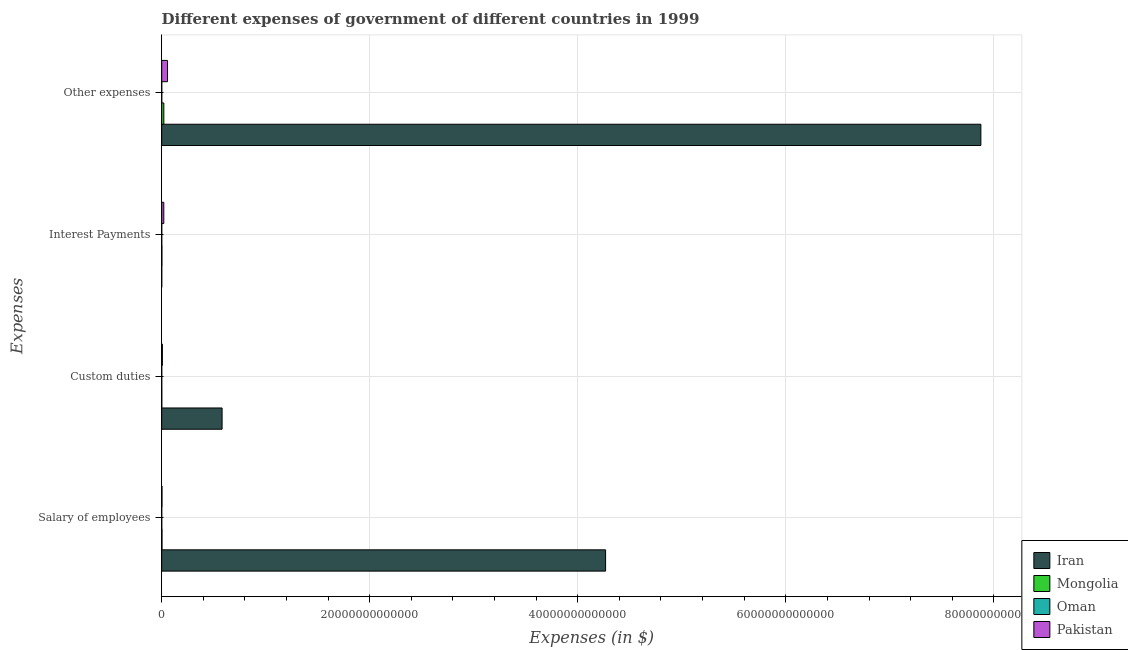How many different coloured bars are there?
Ensure brevity in your answer.  4. Are the number of bars on each tick of the Y-axis equal?
Offer a very short reply. Yes. How many bars are there on the 1st tick from the bottom?
Provide a succinct answer. 4. What is the label of the 4th group of bars from the top?
Your answer should be compact. Salary of employees. What is the amount spent on salary of employees in Iran?
Your answer should be compact. 4.27e+13. Across all countries, what is the maximum amount spent on custom duties?
Your answer should be very brief. 5.81e+12. Across all countries, what is the minimum amount spent on salary of employees?
Keep it short and to the point. 5.70e+08. In which country was the amount spent on other expenses maximum?
Give a very brief answer. Iran. In which country was the amount spent on interest payments minimum?
Keep it short and to the point. Iran. What is the total amount spent on interest payments in the graph?
Provide a short and direct response. 2.17e+11. What is the difference between the amount spent on other expenses in Oman and that in Iran?
Provide a succinct answer. -7.88e+13. What is the difference between the amount spent on other expenses in Pakistan and the amount spent on custom duties in Iran?
Make the answer very short. -5.25e+12. What is the average amount spent on other expenses per country?
Provide a short and direct response. 1.99e+13. What is the difference between the amount spent on salary of employees and amount spent on interest payments in Oman?
Give a very brief answer. 4.71e+08. In how many countries, is the amount spent on interest payments greater than 36000000000000 $?
Ensure brevity in your answer.  0. What is the ratio of the amount spent on interest payments in Mongolia to that in Iran?
Keep it short and to the point. 298.24. Is the difference between the amount spent on interest payments in Mongolia and Iran greater than the difference between the amount spent on salary of employees in Mongolia and Iran?
Make the answer very short. Yes. What is the difference between the highest and the second highest amount spent on other expenses?
Ensure brevity in your answer.  7.82e+13. What is the difference between the highest and the lowest amount spent on custom duties?
Keep it short and to the point. 5.81e+12. In how many countries, is the amount spent on salary of employees greater than the average amount spent on salary of employees taken over all countries?
Provide a short and direct response. 1. Is the sum of the amount spent on interest payments in Mongolia and Pakistan greater than the maximum amount spent on salary of employees across all countries?
Your response must be concise. No. Is it the case that in every country, the sum of the amount spent on interest payments and amount spent on other expenses is greater than the sum of amount spent on salary of employees and amount spent on custom duties?
Ensure brevity in your answer.  No. What does the 4th bar from the top in Salary of employees represents?
Give a very brief answer. Iran. What does the 3rd bar from the bottom in Salary of employees represents?
Your response must be concise. Oman. Is it the case that in every country, the sum of the amount spent on salary of employees and amount spent on custom duties is greater than the amount spent on interest payments?
Make the answer very short. No. How many bars are there?
Your answer should be compact. 16. How many countries are there in the graph?
Provide a short and direct response. 4. What is the difference between two consecutive major ticks on the X-axis?
Give a very brief answer. 2.00e+13. Does the graph contain any zero values?
Your answer should be compact. No. Where does the legend appear in the graph?
Your response must be concise. Bottom right. How many legend labels are there?
Your response must be concise. 4. What is the title of the graph?
Make the answer very short. Different expenses of government of different countries in 1999. What is the label or title of the X-axis?
Make the answer very short. Expenses (in $). What is the label or title of the Y-axis?
Offer a very short reply. Expenses. What is the Expenses (in $) of Iran in Salary of employees?
Offer a terse response. 4.27e+13. What is the Expenses (in $) of Mongolia in Salary of employees?
Keep it short and to the point. 2.57e+1. What is the Expenses (in $) of Oman in Salary of employees?
Your response must be concise. 5.70e+08. What is the Expenses (in $) of Pakistan in Salary of employees?
Offer a terse response. 2.48e+1. What is the Expenses (in $) of Iran in Custom duties?
Your response must be concise. 5.81e+12. What is the Expenses (in $) in Mongolia in Custom duties?
Give a very brief answer. 5.85e+09. What is the Expenses (in $) in Oman in Custom duties?
Your answer should be very brief. 8.03e+07. What is the Expenses (in $) in Pakistan in Custom duties?
Give a very brief answer. 6.53e+1. What is the Expenses (in $) of Iran in Interest Payments?
Offer a very short reply. 5.80e+07. What is the Expenses (in $) of Mongolia in Interest Payments?
Your answer should be compact. 1.73e+1. What is the Expenses (in $) of Oman in Interest Payments?
Provide a short and direct response. 9.88e+07. What is the Expenses (in $) of Pakistan in Interest Payments?
Offer a terse response. 2.00e+11. What is the Expenses (in $) of Iran in Other expenses?
Give a very brief answer. 7.88e+13. What is the Expenses (in $) of Mongolia in Other expenses?
Give a very brief answer. 2.04e+11. What is the Expenses (in $) in Oman in Other expenses?
Make the answer very short. 1.71e+09. What is the Expenses (in $) in Pakistan in Other expenses?
Your response must be concise. 5.58e+11. Across all Expenses, what is the maximum Expenses (in $) in Iran?
Provide a succinct answer. 7.88e+13. Across all Expenses, what is the maximum Expenses (in $) of Mongolia?
Keep it short and to the point. 2.04e+11. Across all Expenses, what is the maximum Expenses (in $) in Oman?
Ensure brevity in your answer.  1.71e+09. Across all Expenses, what is the maximum Expenses (in $) in Pakistan?
Offer a very short reply. 5.58e+11. Across all Expenses, what is the minimum Expenses (in $) of Iran?
Keep it short and to the point. 5.80e+07. Across all Expenses, what is the minimum Expenses (in $) in Mongolia?
Provide a short and direct response. 5.85e+09. Across all Expenses, what is the minimum Expenses (in $) of Oman?
Your response must be concise. 8.03e+07. Across all Expenses, what is the minimum Expenses (in $) of Pakistan?
Your answer should be compact. 2.48e+1. What is the total Expenses (in $) of Iran in the graph?
Keep it short and to the point. 1.27e+14. What is the total Expenses (in $) in Mongolia in the graph?
Your response must be concise. 2.53e+11. What is the total Expenses (in $) of Oman in the graph?
Give a very brief answer. 2.46e+09. What is the total Expenses (in $) in Pakistan in the graph?
Your response must be concise. 8.48e+11. What is the difference between the Expenses (in $) of Iran in Salary of employees and that in Custom duties?
Keep it short and to the point. 3.69e+13. What is the difference between the Expenses (in $) of Mongolia in Salary of employees and that in Custom duties?
Ensure brevity in your answer.  1.98e+1. What is the difference between the Expenses (in $) of Oman in Salary of employees and that in Custom duties?
Offer a very short reply. 4.89e+08. What is the difference between the Expenses (in $) in Pakistan in Salary of employees and that in Custom duties?
Offer a very short reply. -4.05e+1. What is the difference between the Expenses (in $) in Iran in Salary of employees and that in Interest Payments?
Keep it short and to the point. 4.27e+13. What is the difference between the Expenses (in $) in Mongolia in Salary of employees and that in Interest Payments?
Give a very brief answer. 8.39e+09. What is the difference between the Expenses (in $) of Oman in Salary of employees and that in Interest Payments?
Make the answer very short. 4.71e+08. What is the difference between the Expenses (in $) of Pakistan in Salary of employees and that in Interest Payments?
Your answer should be very brief. -1.75e+11. What is the difference between the Expenses (in $) of Iran in Salary of employees and that in Other expenses?
Offer a terse response. -3.61e+13. What is the difference between the Expenses (in $) in Mongolia in Salary of employees and that in Other expenses?
Give a very brief answer. -1.79e+11. What is the difference between the Expenses (in $) in Oman in Salary of employees and that in Other expenses?
Your response must be concise. -1.14e+09. What is the difference between the Expenses (in $) in Pakistan in Salary of employees and that in Other expenses?
Ensure brevity in your answer.  -5.33e+11. What is the difference between the Expenses (in $) in Iran in Custom duties and that in Interest Payments?
Provide a short and direct response. 5.81e+12. What is the difference between the Expenses (in $) in Mongolia in Custom duties and that in Interest Payments?
Make the answer very short. -1.14e+1. What is the difference between the Expenses (in $) in Oman in Custom duties and that in Interest Payments?
Offer a very short reply. -1.85e+07. What is the difference between the Expenses (in $) in Pakistan in Custom duties and that in Interest Payments?
Your answer should be very brief. -1.35e+11. What is the difference between the Expenses (in $) in Iran in Custom duties and that in Other expenses?
Offer a very short reply. -7.29e+13. What is the difference between the Expenses (in $) of Mongolia in Custom duties and that in Other expenses?
Your answer should be very brief. -1.99e+11. What is the difference between the Expenses (in $) in Oman in Custom duties and that in Other expenses?
Your answer should be very brief. -1.63e+09. What is the difference between the Expenses (in $) of Pakistan in Custom duties and that in Other expenses?
Your response must be concise. -4.93e+11. What is the difference between the Expenses (in $) of Iran in Interest Payments and that in Other expenses?
Provide a short and direct response. -7.88e+13. What is the difference between the Expenses (in $) in Mongolia in Interest Payments and that in Other expenses?
Your answer should be compact. -1.87e+11. What is the difference between the Expenses (in $) in Oman in Interest Payments and that in Other expenses?
Provide a short and direct response. -1.62e+09. What is the difference between the Expenses (in $) in Pakistan in Interest Payments and that in Other expenses?
Offer a terse response. -3.58e+11. What is the difference between the Expenses (in $) in Iran in Salary of employees and the Expenses (in $) in Mongolia in Custom duties?
Make the answer very short. 4.27e+13. What is the difference between the Expenses (in $) in Iran in Salary of employees and the Expenses (in $) in Oman in Custom duties?
Your answer should be very brief. 4.27e+13. What is the difference between the Expenses (in $) in Iran in Salary of employees and the Expenses (in $) in Pakistan in Custom duties?
Keep it short and to the point. 4.26e+13. What is the difference between the Expenses (in $) in Mongolia in Salary of employees and the Expenses (in $) in Oman in Custom duties?
Your answer should be very brief. 2.56e+1. What is the difference between the Expenses (in $) in Mongolia in Salary of employees and the Expenses (in $) in Pakistan in Custom duties?
Provide a short and direct response. -3.96e+1. What is the difference between the Expenses (in $) of Oman in Salary of employees and the Expenses (in $) of Pakistan in Custom duties?
Provide a succinct answer. -6.47e+1. What is the difference between the Expenses (in $) of Iran in Salary of employees and the Expenses (in $) of Mongolia in Interest Payments?
Keep it short and to the point. 4.27e+13. What is the difference between the Expenses (in $) in Iran in Salary of employees and the Expenses (in $) in Oman in Interest Payments?
Provide a succinct answer. 4.27e+13. What is the difference between the Expenses (in $) of Iran in Salary of employees and the Expenses (in $) of Pakistan in Interest Payments?
Your response must be concise. 4.25e+13. What is the difference between the Expenses (in $) in Mongolia in Salary of employees and the Expenses (in $) in Oman in Interest Payments?
Ensure brevity in your answer.  2.56e+1. What is the difference between the Expenses (in $) of Mongolia in Salary of employees and the Expenses (in $) of Pakistan in Interest Payments?
Your response must be concise. -1.74e+11. What is the difference between the Expenses (in $) of Oman in Salary of employees and the Expenses (in $) of Pakistan in Interest Payments?
Your answer should be very brief. -1.99e+11. What is the difference between the Expenses (in $) in Iran in Salary of employees and the Expenses (in $) in Mongolia in Other expenses?
Give a very brief answer. 4.25e+13. What is the difference between the Expenses (in $) in Iran in Salary of employees and the Expenses (in $) in Oman in Other expenses?
Your response must be concise. 4.27e+13. What is the difference between the Expenses (in $) of Iran in Salary of employees and the Expenses (in $) of Pakistan in Other expenses?
Provide a succinct answer. 4.21e+13. What is the difference between the Expenses (in $) in Mongolia in Salary of employees and the Expenses (in $) in Oman in Other expenses?
Your response must be concise. 2.40e+1. What is the difference between the Expenses (in $) in Mongolia in Salary of employees and the Expenses (in $) in Pakistan in Other expenses?
Give a very brief answer. -5.32e+11. What is the difference between the Expenses (in $) of Oman in Salary of employees and the Expenses (in $) of Pakistan in Other expenses?
Keep it short and to the point. -5.58e+11. What is the difference between the Expenses (in $) of Iran in Custom duties and the Expenses (in $) of Mongolia in Interest Payments?
Make the answer very short. 5.79e+12. What is the difference between the Expenses (in $) of Iran in Custom duties and the Expenses (in $) of Oman in Interest Payments?
Keep it short and to the point. 5.81e+12. What is the difference between the Expenses (in $) of Iran in Custom duties and the Expenses (in $) of Pakistan in Interest Payments?
Offer a terse response. 5.61e+12. What is the difference between the Expenses (in $) of Mongolia in Custom duties and the Expenses (in $) of Oman in Interest Payments?
Make the answer very short. 5.75e+09. What is the difference between the Expenses (in $) of Mongolia in Custom duties and the Expenses (in $) of Pakistan in Interest Payments?
Give a very brief answer. -1.94e+11. What is the difference between the Expenses (in $) in Oman in Custom duties and the Expenses (in $) in Pakistan in Interest Payments?
Provide a short and direct response. -2.00e+11. What is the difference between the Expenses (in $) of Iran in Custom duties and the Expenses (in $) of Mongolia in Other expenses?
Your answer should be very brief. 5.60e+12. What is the difference between the Expenses (in $) of Iran in Custom duties and the Expenses (in $) of Oman in Other expenses?
Provide a short and direct response. 5.80e+12. What is the difference between the Expenses (in $) in Iran in Custom duties and the Expenses (in $) in Pakistan in Other expenses?
Offer a terse response. 5.25e+12. What is the difference between the Expenses (in $) in Mongolia in Custom duties and the Expenses (in $) in Oman in Other expenses?
Your answer should be compact. 4.14e+09. What is the difference between the Expenses (in $) in Mongolia in Custom duties and the Expenses (in $) in Pakistan in Other expenses?
Your response must be concise. -5.52e+11. What is the difference between the Expenses (in $) of Oman in Custom duties and the Expenses (in $) of Pakistan in Other expenses?
Your response must be concise. -5.58e+11. What is the difference between the Expenses (in $) in Iran in Interest Payments and the Expenses (in $) in Mongolia in Other expenses?
Your answer should be compact. -2.04e+11. What is the difference between the Expenses (in $) of Iran in Interest Payments and the Expenses (in $) of Oman in Other expenses?
Provide a short and direct response. -1.66e+09. What is the difference between the Expenses (in $) in Iran in Interest Payments and the Expenses (in $) in Pakistan in Other expenses?
Your answer should be very brief. -5.58e+11. What is the difference between the Expenses (in $) of Mongolia in Interest Payments and the Expenses (in $) of Oman in Other expenses?
Provide a succinct answer. 1.56e+1. What is the difference between the Expenses (in $) in Mongolia in Interest Payments and the Expenses (in $) in Pakistan in Other expenses?
Offer a very short reply. -5.41e+11. What is the difference between the Expenses (in $) of Oman in Interest Payments and the Expenses (in $) of Pakistan in Other expenses?
Your response must be concise. -5.58e+11. What is the average Expenses (in $) in Iran per Expenses?
Ensure brevity in your answer.  3.18e+13. What is the average Expenses (in $) in Mongolia per Expenses?
Provide a short and direct response. 6.33e+1. What is the average Expenses (in $) in Oman per Expenses?
Offer a very short reply. 6.16e+08. What is the average Expenses (in $) of Pakistan per Expenses?
Your answer should be compact. 2.12e+11. What is the difference between the Expenses (in $) in Iran and Expenses (in $) in Mongolia in Salary of employees?
Your answer should be compact. 4.26e+13. What is the difference between the Expenses (in $) in Iran and Expenses (in $) in Oman in Salary of employees?
Offer a very short reply. 4.27e+13. What is the difference between the Expenses (in $) in Iran and Expenses (in $) in Pakistan in Salary of employees?
Give a very brief answer. 4.26e+13. What is the difference between the Expenses (in $) of Mongolia and Expenses (in $) of Oman in Salary of employees?
Your answer should be compact. 2.51e+1. What is the difference between the Expenses (in $) of Mongolia and Expenses (in $) of Pakistan in Salary of employees?
Provide a short and direct response. 8.74e+08. What is the difference between the Expenses (in $) of Oman and Expenses (in $) of Pakistan in Salary of employees?
Your answer should be compact. -2.42e+1. What is the difference between the Expenses (in $) in Iran and Expenses (in $) in Mongolia in Custom duties?
Keep it short and to the point. 5.80e+12. What is the difference between the Expenses (in $) of Iran and Expenses (in $) of Oman in Custom duties?
Offer a very short reply. 5.81e+12. What is the difference between the Expenses (in $) of Iran and Expenses (in $) of Pakistan in Custom duties?
Make the answer very short. 5.74e+12. What is the difference between the Expenses (in $) of Mongolia and Expenses (in $) of Oman in Custom duties?
Your answer should be compact. 5.77e+09. What is the difference between the Expenses (in $) of Mongolia and Expenses (in $) of Pakistan in Custom duties?
Ensure brevity in your answer.  -5.94e+1. What is the difference between the Expenses (in $) in Oman and Expenses (in $) in Pakistan in Custom duties?
Provide a short and direct response. -6.52e+1. What is the difference between the Expenses (in $) in Iran and Expenses (in $) in Mongolia in Interest Payments?
Keep it short and to the point. -1.72e+1. What is the difference between the Expenses (in $) of Iran and Expenses (in $) of Oman in Interest Payments?
Ensure brevity in your answer.  -4.08e+07. What is the difference between the Expenses (in $) in Iran and Expenses (in $) in Pakistan in Interest Payments?
Your response must be concise. -2.00e+11. What is the difference between the Expenses (in $) in Mongolia and Expenses (in $) in Oman in Interest Payments?
Offer a terse response. 1.72e+1. What is the difference between the Expenses (in $) in Mongolia and Expenses (in $) in Pakistan in Interest Payments?
Your answer should be very brief. -1.83e+11. What is the difference between the Expenses (in $) of Oman and Expenses (in $) of Pakistan in Interest Payments?
Offer a terse response. -2.00e+11. What is the difference between the Expenses (in $) of Iran and Expenses (in $) of Mongolia in Other expenses?
Offer a terse response. 7.86e+13. What is the difference between the Expenses (in $) of Iran and Expenses (in $) of Oman in Other expenses?
Ensure brevity in your answer.  7.88e+13. What is the difference between the Expenses (in $) of Iran and Expenses (in $) of Pakistan in Other expenses?
Make the answer very short. 7.82e+13. What is the difference between the Expenses (in $) of Mongolia and Expenses (in $) of Oman in Other expenses?
Your answer should be compact. 2.03e+11. What is the difference between the Expenses (in $) in Mongolia and Expenses (in $) in Pakistan in Other expenses?
Ensure brevity in your answer.  -3.54e+11. What is the difference between the Expenses (in $) of Oman and Expenses (in $) of Pakistan in Other expenses?
Your answer should be very brief. -5.56e+11. What is the ratio of the Expenses (in $) in Iran in Salary of employees to that in Custom duties?
Offer a very short reply. 7.35. What is the ratio of the Expenses (in $) of Mongolia in Salary of employees to that in Custom duties?
Keep it short and to the point. 4.39. What is the ratio of the Expenses (in $) in Oman in Salary of employees to that in Custom duties?
Make the answer very short. 7.09. What is the ratio of the Expenses (in $) of Pakistan in Salary of employees to that in Custom duties?
Make the answer very short. 0.38. What is the ratio of the Expenses (in $) of Iran in Salary of employees to that in Interest Payments?
Your response must be concise. 7.36e+05. What is the ratio of the Expenses (in $) of Mongolia in Salary of employees to that in Interest Payments?
Keep it short and to the point. 1.49. What is the ratio of the Expenses (in $) of Oman in Salary of employees to that in Interest Payments?
Give a very brief answer. 5.77. What is the ratio of the Expenses (in $) in Pakistan in Salary of employees to that in Interest Payments?
Keep it short and to the point. 0.12. What is the ratio of the Expenses (in $) in Iran in Salary of employees to that in Other expenses?
Make the answer very short. 0.54. What is the ratio of the Expenses (in $) of Mongolia in Salary of employees to that in Other expenses?
Give a very brief answer. 0.13. What is the ratio of the Expenses (in $) of Oman in Salary of employees to that in Other expenses?
Your answer should be very brief. 0.33. What is the ratio of the Expenses (in $) in Pakistan in Salary of employees to that in Other expenses?
Your response must be concise. 0.04. What is the ratio of the Expenses (in $) of Iran in Custom duties to that in Interest Payments?
Provide a succinct answer. 1.00e+05. What is the ratio of the Expenses (in $) of Mongolia in Custom duties to that in Interest Payments?
Ensure brevity in your answer.  0.34. What is the ratio of the Expenses (in $) in Oman in Custom duties to that in Interest Payments?
Your answer should be compact. 0.81. What is the ratio of the Expenses (in $) in Pakistan in Custom duties to that in Interest Payments?
Ensure brevity in your answer.  0.33. What is the ratio of the Expenses (in $) of Iran in Custom duties to that in Other expenses?
Your answer should be very brief. 0.07. What is the ratio of the Expenses (in $) of Mongolia in Custom duties to that in Other expenses?
Ensure brevity in your answer.  0.03. What is the ratio of the Expenses (in $) in Oman in Custom duties to that in Other expenses?
Make the answer very short. 0.05. What is the ratio of the Expenses (in $) of Pakistan in Custom duties to that in Other expenses?
Your response must be concise. 0.12. What is the ratio of the Expenses (in $) in Iran in Interest Payments to that in Other expenses?
Keep it short and to the point. 0. What is the ratio of the Expenses (in $) in Mongolia in Interest Payments to that in Other expenses?
Make the answer very short. 0.08. What is the ratio of the Expenses (in $) in Oman in Interest Payments to that in Other expenses?
Give a very brief answer. 0.06. What is the ratio of the Expenses (in $) of Pakistan in Interest Payments to that in Other expenses?
Offer a terse response. 0.36. What is the difference between the highest and the second highest Expenses (in $) of Iran?
Keep it short and to the point. 3.61e+13. What is the difference between the highest and the second highest Expenses (in $) in Mongolia?
Provide a succinct answer. 1.79e+11. What is the difference between the highest and the second highest Expenses (in $) in Oman?
Give a very brief answer. 1.14e+09. What is the difference between the highest and the second highest Expenses (in $) in Pakistan?
Keep it short and to the point. 3.58e+11. What is the difference between the highest and the lowest Expenses (in $) of Iran?
Make the answer very short. 7.88e+13. What is the difference between the highest and the lowest Expenses (in $) of Mongolia?
Provide a succinct answer. 1.99e+11. What is the difference between the highest and the lowest Expenses (in $) of Oman?
Your response must be concise. 1.63e+09. What is the difference between the highest and the lowest Expenses (in $) in Pakistan?
Your answer should be very brief. 5.33e+11. 